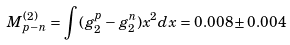<formula> <loc_0><loc_0><loc_500><loc_500>M _ { p - n } ^ { ( 2 ) } = \int { ( g _ { 2 } ^ { p } - g _ { 2 } ^ { n } ) x ^ { 2 } d x } = 0 . 0 0 8 \pm 0 . 0 0 4</formula> 